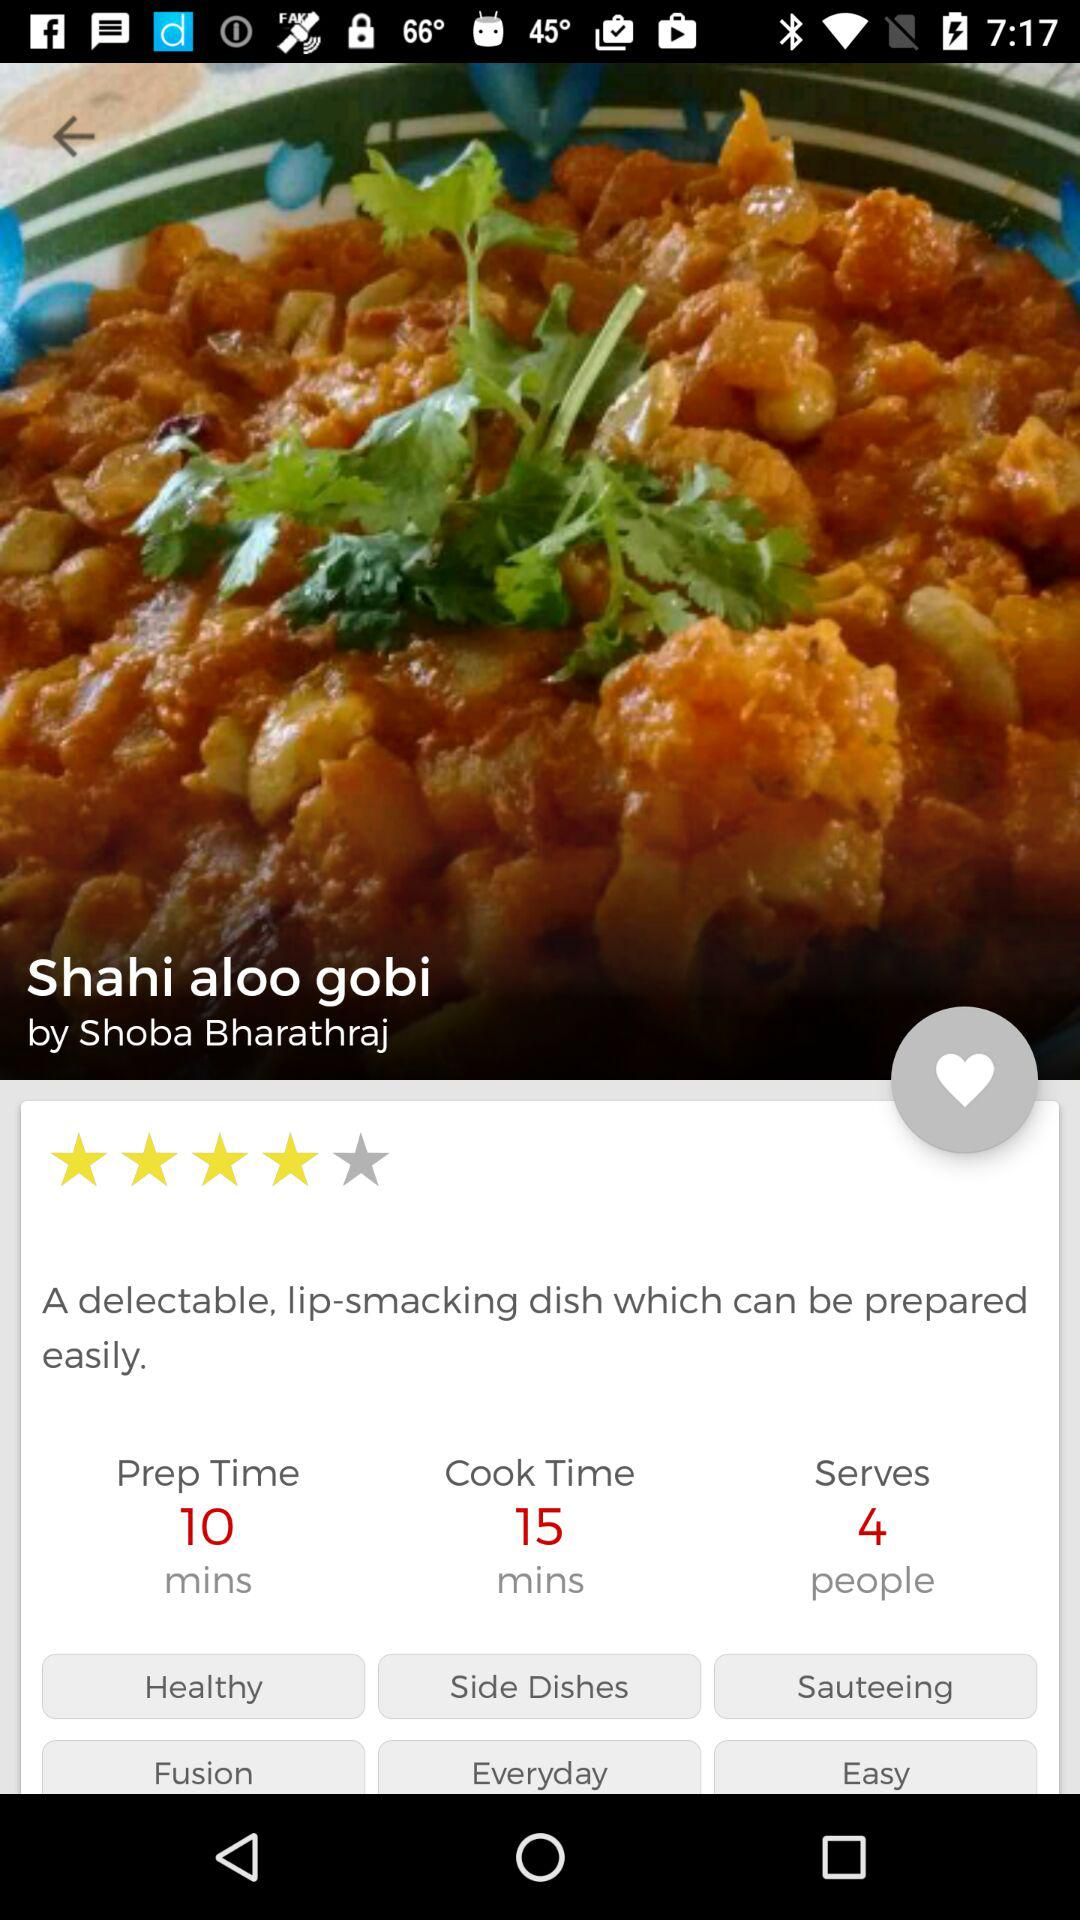What is the preparation time? The preparation time is 10 minutes. 